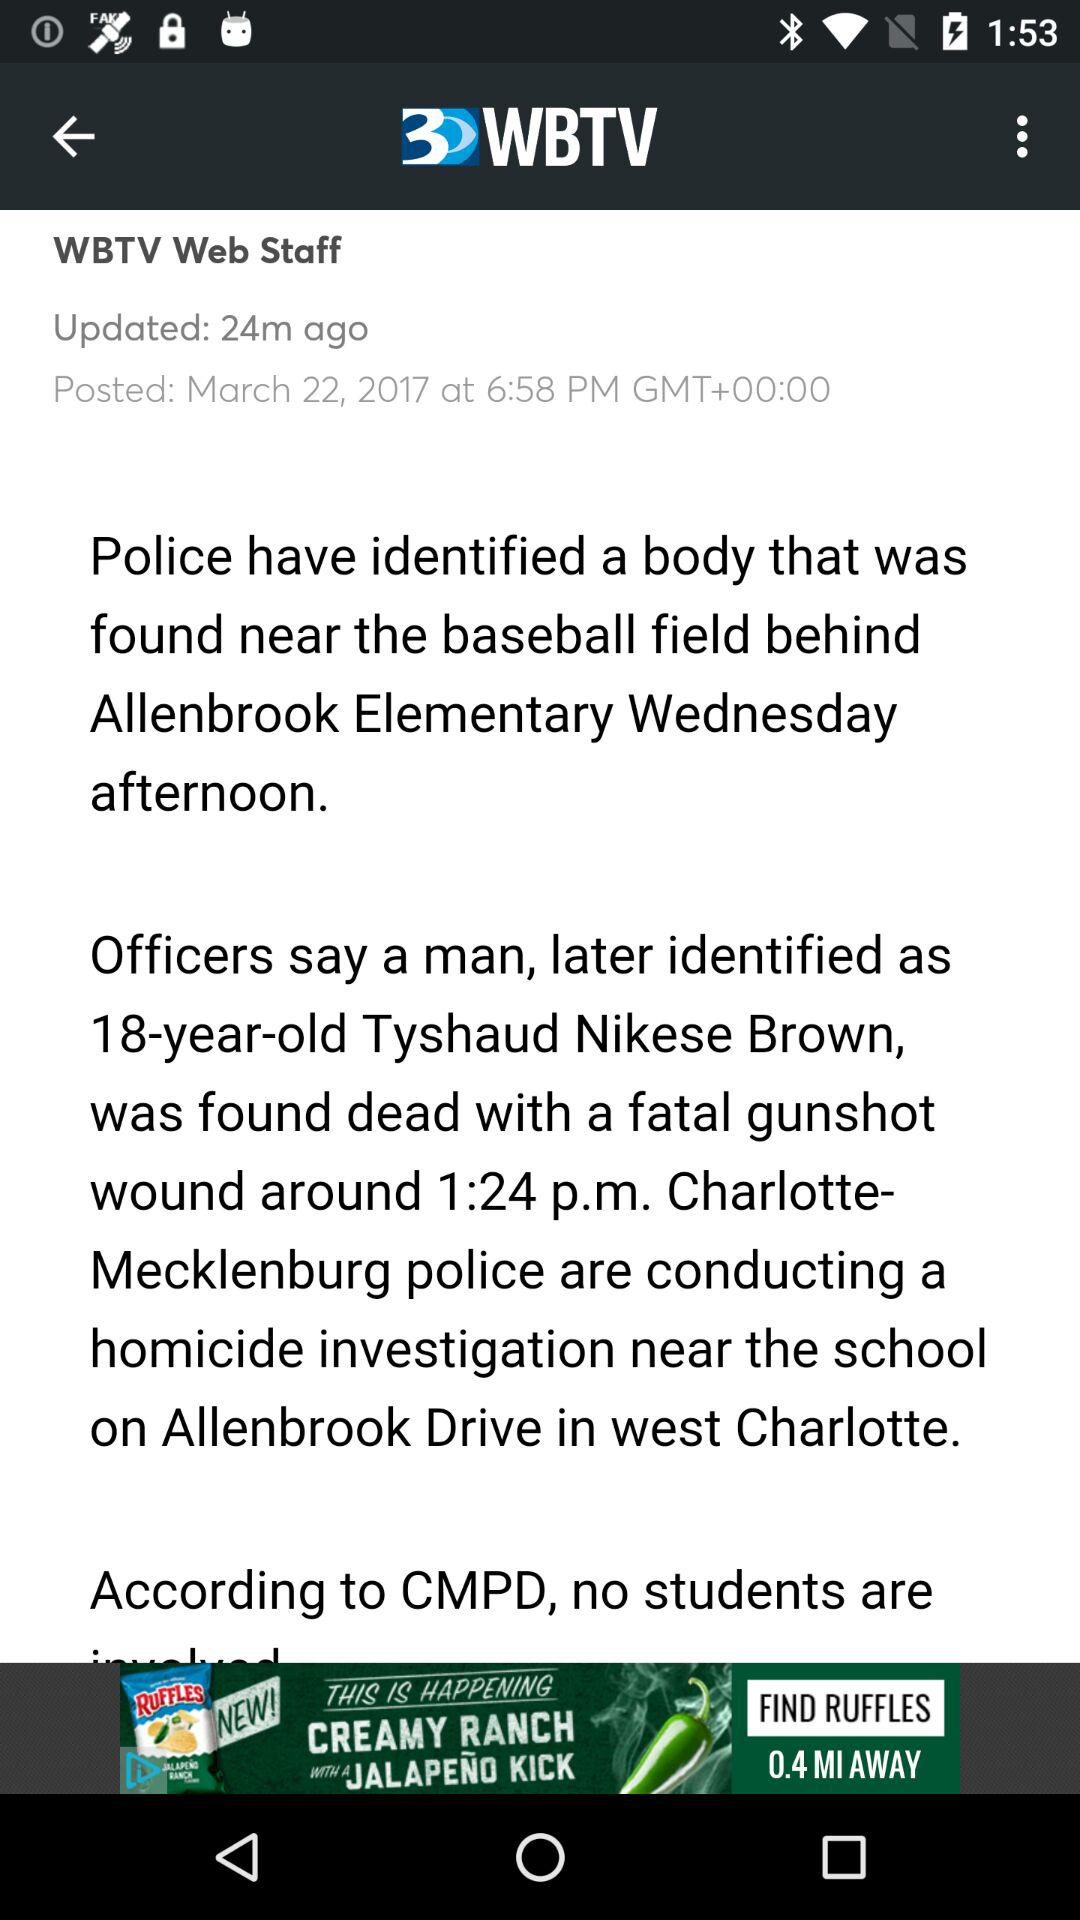When was the article posted? The article was posted on March 22, 2017 at 6:58 PM. 